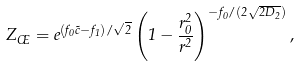Convert formula to latex. <formula><loc_0><loc_0><loc_500><loc_500>Z _ { \phi } = e ^ { ( f _ { 0 } \tilde { c } - f _ { 1 } ) / \sqrt { 2 } } \left ( 1 - \frac { r _ { 0 } ^ { 2 } } { r ^ { 2 } } \right ) ^ { - f _ { 0 } / ( 2 \sqrt { 2 D _ { 2 } } ) } ,</formula> 